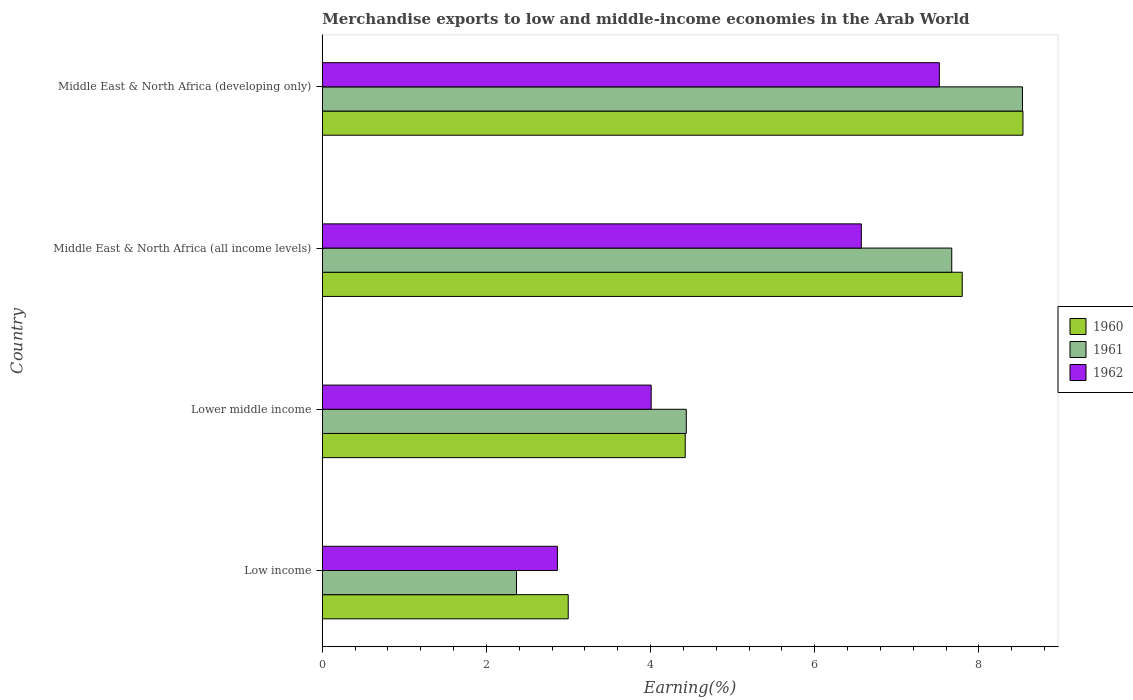How many different coloured bars are there?
Provide a short and direct response. 3. How many groups of bars are there?
Offer a very short reply. 4. Are the number of bars per tick equal to the number of legend labels?
Your answer should be very brief. Yes. Are the number of bars on each tick of the Y-axis equal?
Your response must be concise. Yes. What is the label of the 3rd group of bars from the top?
Ensure brevity in your answer.  Lower middle income. In how many cases, is the number of bars for a given country not equal to the number of legend labels?
Your response must be concise. 0. What is the percentage of amount earned from merchandise exports in 1962 in Low income?
Offer a very short reply. 2.86. Across all countries, what is the maximum percentage of amount earned from merchandise exports in 1961?
Keep it short and to the point. 8.53. Across all countries, what is the minimum percentage of amount earned from merchandise exports in 1960?
Offer a terse response. 3. In which country was the percentage of amount earned from merchandise exports in 1962 maximum?
Your answer should be very brief. Middle East & North Africa (developing only). What is the total percentage of amount earned from merchandise exports in 1962 in the graph?
Give a very brief answer. 20.96. What is the difference between the percentage of amount earned from merchandise exports in 1962 in Lower middle income and that in Middle East & North Africa (all income levels)?
Offer a very short reply. -2.56. What is the difference between the percentage of amount earned from merchandise exports in 1961 in Lower middle income and the percentage of amount earned from merchandise exports in 1962 in Middle East & North Africa (developing only)?
Give a very brief answer. -3.08. What is the average percentage of amount earned from merchandise exports in 1962 per country?
Give a very brief answer. 5.24. What is the difference between the percentage of amount earned from merchandise exports in 1960 and percentage of amount earned from merchandise exports in 1962 in Low income?
Your response must be concise. 0.13. What is the ratio of the percentage of amount earned from merchandise exports in 1961 in Low income to that in Middle East & North Africa (developing only)?
Offer a terse response. 0.28. Is the percentage of amount earned from merchandise exports in 1961 in Low income less than that in Middle East & North Africa (developing only)?
Provide a succinct answer. Yes. What is the difference between the highest and the second highest percentage of amount earned from merchandise exports in 1961?
Provide a short and direct response. 0.86. What is the difference between the highest and the lowest percentage of amount earned from merchandise exports in 1960?
Your answer should be very brief. 5.54. In how many countries, is the percentage of amount earned from merchandise exports in 1962 greater than the average percentage of amount earned from merchandise exports in 1962 taken over all countries?
Your answer should be compact. 2. What does the 1st bar from the top in Lower middle income represents?
Your response must be concise. 1962. What is the difference between two consecutive major ticks on the X-axis?
Keep it short and to the point. 2. Does the graph contain any zero values?
Keep it short and to the point. No. Where does the legend appear in the graph?
Provide a succinct answer. Center right. How are the legend labels stacked?
Provide a succinct answer. Vertical. What is the title of the graph?
Your response must be concise. Merchandise exports to low and middle-income economies in the Arab World. What is the label or title of the X-axis?
Ensure brevity in your answer.  Earning(%). What is the Earning(%) of 1960 in Low income?
Your answer should be very brief. 3. What is the Earning(%) of 1961 in Low income?
Ensure brevity in your answer.  2.37. What is the Earning(%) of 1962 in Low income?
Ensure brevity in your answer.  2.86. What is the Earning(%) of 1960 in Lower middle income?
Provide a short and direct response. 4.42. What is the Earning(%) in 1961 in Lower middle income?
Provide a short and direct response. 4.43. What is the Earning(%) in 1962 in Lower middle income?
Provide a succinct answer. 4.01. What is the Earning(%) in 1960 in Middle East & North Africa (all income levels)?
Your answer should be compact. 7.8. What is the Earning(%) of 1961 in Middle East & North Africa (all income levels)?
Make the answer very short. 7.67. What is the Earning(%) of 1962 in Middle East & North Africa (all income levels)?
Make the answer very short. 6.57. What is the Earning(%) of 1960 in Middle East & North Africa (developing only)?
Keep it short and to the point. 8.54. What is the Earning(%) of 1961 in Middle East & North Africa (developing only)?
Provide a short and direct response. 8.53. What is the Earning(%) in 1962 in Middle East & North Africa (developing only)?
Keep it short and to the point. 7.52. Across all countries, what is the maximum Earning(%) in 1960?
Your answer should be very brief. 8.54. Across all countries, what is the maximum Earning(%) of 1961?
Offer a very short reply. 8.53. Across all countries, what is the maximum Earning(%) in 1962?
Offer a very short reply. 7.52. Across all countries, what is the minimum Earning(%) of 1960?
Provide a short and direct response. 3. Across all countries, what is the minimum Earning(%) in 1961?
Your answer should be compact. 2.37. Across all countries, what is the minimum Earning(%) in 1962?
Provide a short and direct response. 2.86. What is the total Earning(%) in 1960 in the graph?
Offer a terse response. 23.75. What is the total Earning(%) of 1961 in the graph?
Keep it short and to the point. 23. What is the total Earning(%) in 1962 in the graph?
Keep it short and to the point. 20.96. What is the difference between the Earning(%) of 1960 in Low income and that in Lower middle income?
Offer a terse response. -1.43. What is the difference between the Earning(%) in 1961 in Low income and that in Lower middle income?
Provide a succinct answer. -2.07. What is the difference between the Earning(%) in 1962 in Low income and that in Lower middle income?
Make the answer very short. -1.14. What is the difference between the Earning(%) in 1960 in Low income and that in Middle East & North Africa (all income levels)?
Your answer should be compact. -4.8. What is the difference between the Earning(%) in 1961 in Low income and that in Middle East & North Africa (all income levels)?
Give a very brief answer. -5.3. What is the difference between the Earning(%) in 1962 in Low income and that in Middle East & North Africa (all income levels)?
Provide a succinct answer. -3.7. What is the difference between the Earning(%) in 1960 in Low income and that in Middle East & North Africa (developing only)?
Provide a short and direct response. -5.54. What is the difference between the Earning(%) in 1961 in Low income and that in Middle East & North Africa (developing only)?
Ensure brevity in your answer.  -6.17. What is the difference between the Earning(%) in 1962 in Low income and that in Middle East & North Africa (developing only)?
Provide a short and direct response. -4.65. What is the difference between the Earning(%) in 1960 in Lower middle income and that in Middle East & North Africa (all income levels)?
Your answer should be very brief. -3.38. What is the difference between the Earning(%) of 1961 in Lower middle income and that in Middle East & North Africa (all income levels)?
Give a very brief answer. -3.23. What is the difference between the Earning(%) of 1962 in Lower middle income and that in Middle East & North Africa (all income levels)?
Provide a succinct answer. -2.56. What is the difference between the Earning(%) of 1960 in Lower middle income and that in Middle East & North Africa (developing only)?
Offer a very short reply. -4.12. What is the difference between the Earning(%) of 1961 in Lower middle income and that in Middle East & North Africa (developing only)?
Offer a terse response. -4.1. What is the difference between the Earning(%) in 1962 in Lower middle income and that in Middle East & North Africa (developing only)?
Your answer should be compact. -3.51. What is the difference between the Earning(%) in 1960 in Middle East & North Africa (all income levels) and that in Middle East & North Africa (developing only)?
Give a very brief answer. -0.74. What is the difference between the Earning(%) in 1961 in Middle East & North Africa (all income levels) and that in Middle East & North Africa (developing only)?
Offer a very short reply. -0.86. What is the difference between the Earning(%) in 1962 in Middle East & North Africa (all income levels) and that in Middle East & North Africa (developing only)?
Make the answer very short. -0.95. What is the difference between the Earning(%) of 1960 in Low income and the Earning(%) of 1961 in Lower middle income?
Provide a short and direct response. -1.44. What is the difference between the Earning(%) in 1960 in Low income and the Earning(%) in 1962 in Lower middle income?
Offer a terse response. -1.01. What is the difference between the Earning(%) in 1961 in Low income and the Earning(%) in 1962 in Lower middle income?
Your answer should be compact. -1.64. What is the difference between the Earning(%) in 1960 in Low income and the Earning(%) in 1961 in Middle East & North Africa (all income levels)?
Offer a terse response. -4.67. What is the difference between the Earning(%) in 1960 in Low income and the Earning(%) in 1962 in Middle East & North Africa (all income levels)?
Your answer should be very brief. -3.57. What is the difference between the Earning(%) of 1961 in Low income and the Earning(%) of 1962 in Middle East & North Africa (all income levels)?
Provide a succinct answer. -4.2. What is the difference between the Earning(%) in 1960 in Low income and the Earning(%) in 1961 in Middle East & North Africa (developing only)?
Provide a short and direct response. -5.54. What is the difference between the Earning(%) of 1960 in Low income and the Earning(%) of 1962 in Middle East & North Africa (developing only)?
Offer a terse response. -4.52. What is the difference between the Earning(%) in 1961 in Low income and the Earning(%) in 1962 in Middle East & North Africa (developing only)?
Offer a terse response. -5.15. What is the difference between the Earning(%) in 1960 in Lower middle income and the Earning(%) in 1961 in Middle East & North Africa (all income levels)?
Your response must be concise. -3.25. What is the difference between the Earning(%) of 1960 in Lower middle income and the Earning(%) of 1962 in Middle East & North Africa (all income levels)?
Keep it short and to the point. -2.15. What is the difference between the Earning(%) of 1961 in Lower middle income and the Earning(%) of 1962 in Middle East & North Africa (all income levels)?
Provide a short and direct response. -2.13. What is the difference between the Earning(%) of 1960 in Lower middle income and the Earning(%) of 1961 in Middle East & North Africa (developing only)?
Your answer should be compact. -4.11. What is the difference between the Earning(%) of 1960 in Lower middle income and the Earning(%) of 1962 in Middle East & North Africa (developing only)?
Offer a terse response. -3.1. What is the difference between the Earning(%) in 1961 in Lower middle income and the Earning(%) in 1962 in Middle East & North Africa (developing only)?
Offer a terse response. -3.08. What is the difference between the Earning(%) of 1960 in Middle East & North Africa (all income levels) and the Earning(%) of 1961 in Middle East & North Africa (developing only)?
Your answer should be very brief. -0.73. What is the difference between the Earning(%) in 1960 in Middle East & North Africa (all income levels) and the Earning(%) in 1962 in Middle East & North Africa (developing only)?
Ensure brevity in your answer.  0.28. What is the difference between the Earning(%) in 1961 in Middle East & North Africa (all income levels) and the Earning(%) in 1962 in Middle East & North Africa (developing only)?
Provide a short and direct response. 0.15. What is the average Earning(%) of 1960 per country?
Offer a very short reply. 5.94. What is the average Earning(%) of 1961 per country?
Provide a short and direct response. 5.75. What is the average Earning(%) in 1962 per country?
Provide a short and direct response. 5.24. What is the difference between the Earning(%) of 1960 and Earning(%) of 1961 in Low income?
Keep it short and to the point. 0.63. What is the difference between the Earning(%) in 1960 and Earning(%) in 1962 in Low income?
Your answer should be compact. 0.13. What is the difference between the Earning(%) in 1961 and Earning(%) in 1962 in Low income?
Give a very brief answer. -0.5. What is the difference between the Earning(%) in 1960 and Earning(%) in 1961 in Lower middle income?
Your answer should be compact. -0.01. What is the difference between the Earning(%) in 1960 and Earning(%) in 1962 in Lower middle income?
Your answer should be compact. 0.41. What is the difference between the Earning(%) of 1961 and Earning(%) of 1962 in Lower middle income?
Give a very brief answer. 0.43. What is the difference between the Earning(%) of 1960 and Earning(%) of 1961 in Middle East & North Africa (all income levels)?
Provide a short and direct response. 0.13. What is the difference between the Earning(%) of 1960 and Earning(%) of 1962 in Middle East & North Africa (all income levels)?
Your answer should be very brief. 1.23. What is the difference between the Earning(%) in 1961 and Earning(%) in 1962 in Middle East & North Africa (all income levels)?
Provide a succinct answer. 1.1. What is the difference between the Earning(%) of 1960 and Earning(%) of 1961 in Middle East & North Africa (developing only)?
Keep it short and to the point. 0.01. What is the difference between the Earning(%) in 1960 and Earning(%) in 1962 in Middle East & North Africa (developing only)?
Offer a terse response. 1.02. What is the difference between the Earning(%) in 1961 and Earning(%) in 1962 in Middle East & North Africa (developing only)?
Your answer should be very brief. 1.01. What is the ratio of the Earning(%) of 1960 in Low income to that in Lower middle income?
Your response must be concise. 0.68. What is the ratio of the Earning(%) in 1961 in Low income to that in Lower middle income?
Offer a terse response. 0.53. What is the ratio of the Earning(%) of 1962 in Low income to that in Lower middle income?
Give a very brief answer. 0.71. What is the ratio of the Earning(%) in 1960 in Low income to that in Middle East & North Africa (all income levels)?
Your response must be concise. 0.38. What is the ratio of the Earning(%) in 1961 in Low income to that in Middle East & North Africa (all income levels)?
Make the answer very short. 0.31. What is the ratio of the Earning(%) in 1962 in Low income to that in Middle East & North Africa (all income levels)?
Provide a short and direct response. 0.44. What is the ratio of the Earning(%) of 1960 in Low income to that in Middle East & North Africa (developing only)?
Your answer should be compact. 0.35. What is the ratio of the Earning(%) in 1961 in Low income to that in Middle East & North Africa (developing only)?
Give a very brief answer. 0.28. What is the ratio of the Earning(%) in 1962 in Low income to that in Middle East & North Africa (developing only)?
Give a very brief answer. 0.38. What is the ratio of the Earning(%) of 1960 in Lower middle income to that in Middle East & North Africa (all income levels)?
Offer a terse response. 0.57. What is the ratio of the Earning(%) in 1961 in Lower middle income to that in Middle East & North Africa (all income levels)?
Ensure brevity in your answer.  0.58. What is the ratio of the Earning(%) in 1962 in Lower middle income to that in Middle East & North Africa (all income levels)?
Make the answer very short. 0.61. What is the ratio of the Earning(%) in 1960 in Lower middle income to that in Middle East & North Africa (developing only)?
Ensure brevity in your answer.  0.52. What is the ratio of the Earning(%) of 1961 in Lower middle income to that in Middle East & North Africa (developing only)?
Provide a short and direct response. 0.52. What is the ratio of the Earning(%) in 1962 in Lower middle income to that in Middle East & North Africa (developing only)?
Provide a short and direct response. 0.53. What is the ratio of the Earning(%) in 1960 in Middle East & North Africa (all income levels) to that in Middle East & North Africa (developing only)?
Your response must be concise. 0.91. What is the ratio of the Earning(%) in 1961 in Middle East & North Africa (all income levels) to that in Middle East & North Africa (developing only)?
Offer a very short reply. 0.9. What is the ratio of the Earning(%) of 1962 in Middle East & North Africa (all income levels) to that in Middle East & North Africa (developing only)?
Keep it short and to the point. 0.87. What is the difference between the highest and the second highest Earning(%) of 1960?
Ensure brevity in your answer.  0.74. What is the difference between the highest and the second highest Earning(%) of 1961?
Your response must be concise. 0.86. What is the difference between the highest and the second highest Earning(%) in 1962?
Your answer should be compact. 0.95. What is the difference between the highest and the lowest Earning(%) of 1960?
Your answer should be very brief. 5.54. What is the difference between the highest and the lowest Earning(%) in 1961?
Your answer should be very brief. 6.17. What is the difference between the highest and the lowest Earning(%) of 1962?
Your answer should be compact. 4.65. 